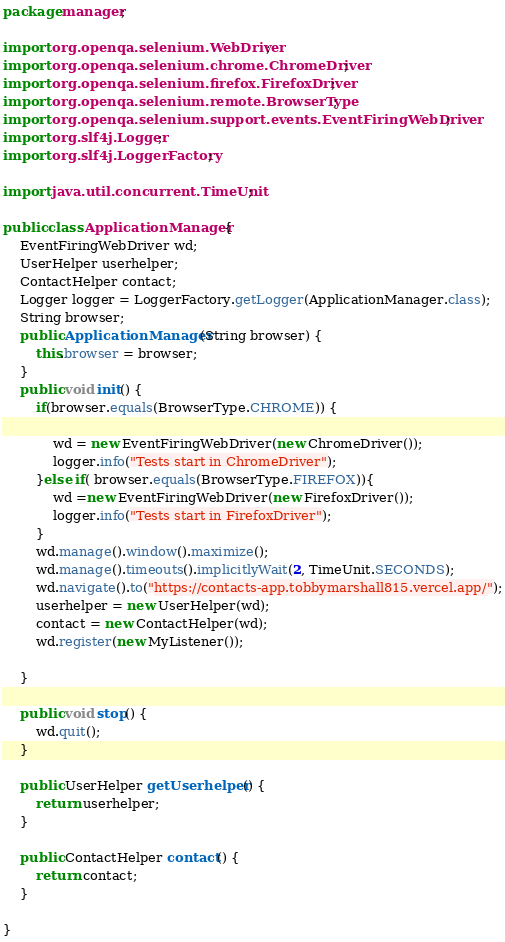Convert code to text. <code><loc_0><loc_0><loc_500><loc_500><_Java_>package manager;

import org.openqa.selenium.WebDriver;
import org.openqa.selenium.chrome.ChromeDriver;
import org.openqa.selenium.firefox.FirefoxDriver;
import org.openqa.selenium.remote.BrowserType;
import org.openqa.selenium.support.events.EventFiringWebDriver;
import org.slf4j.Logger;
import org.slf4j.LoggerFactory;

import java.util.concurrent.TimeUnit;

public class ApplicationManager {
    EventFiringWebDriver wd;
    UserHelper userhelper;
    ContactHelper contact;
    Logger logger = LoggerFactory.getLogger(ApplicationManager.class);
    String browser;
    public ApplicationManager(String browser) {
        this.browser = browser;
    }
    public void init() {
        if(browser.equals(BrowserType.CHROME)) {

            wd = new EventFiringWebDriver(new ChromeDriver());
            logger.info("Tests start in ChromeDriver");
        }else if( browser.equals(BrowserType.FIREFOX)){
            wd =new EventFiringWebDriver(new FirefoxDriver());
            logger.info("Tests start in FirefoxDriver");
        }
        wd.manage().window().maximize();
        wd.manage().timeouts().implicitlyWait(2, TimeUnit.SECONDS);
        wd.navigate().to("https://contacts-app.tobbymarshall815.vercel.app/");
        userhelper = new UserHelper(wd);
        contact = new ContactHelper(wd);
        wd.register(new MyListener());

    }

    public void stop() {
        wd.quit();
    }

    public UserHelper getUserhelper() {
        return userhelper;
    }

    public ContactHelper contact() {
        return contact;
    }

}</code> 